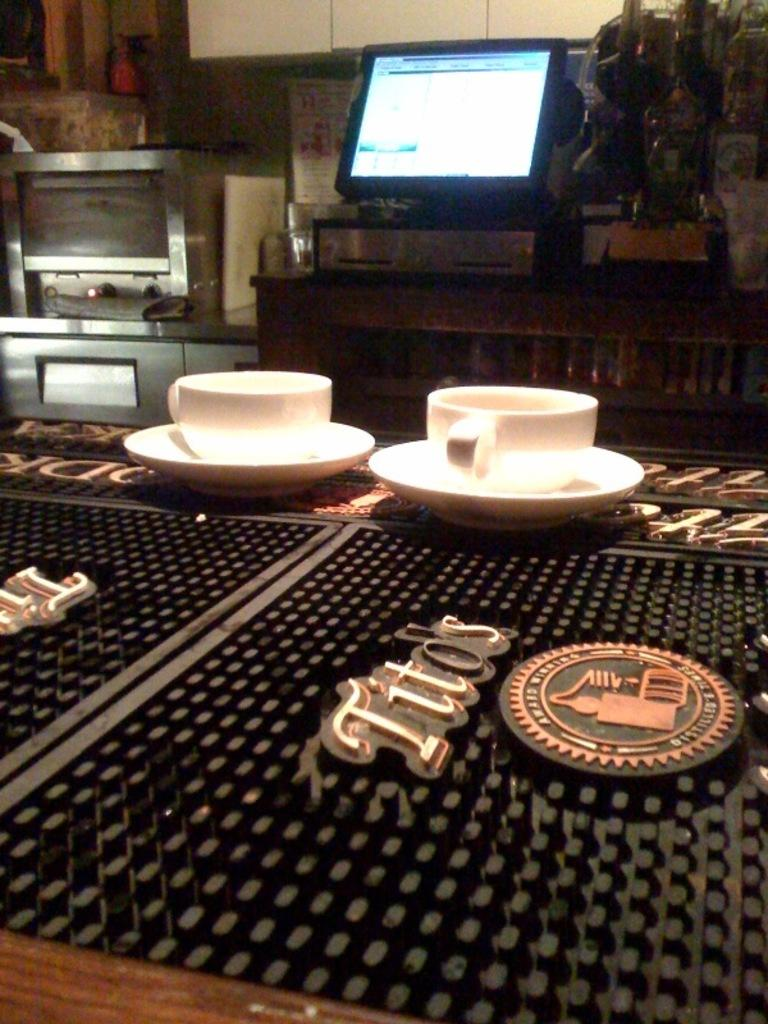What objects are on the table in the image? There are cups on a table in the image. What appliance can be seen on the left side of the image? There is a microwave oven on the left side of the image. What electronic device is present in the image? There is a monitor screen in the image. What committee is meeting in the image? There is no committee meeting in the image; it only shows cups on a table, a microwave oven, and a monitor screen. What role does the father play in the image? There is no father present in the image, so it is not possible to determine his role. 